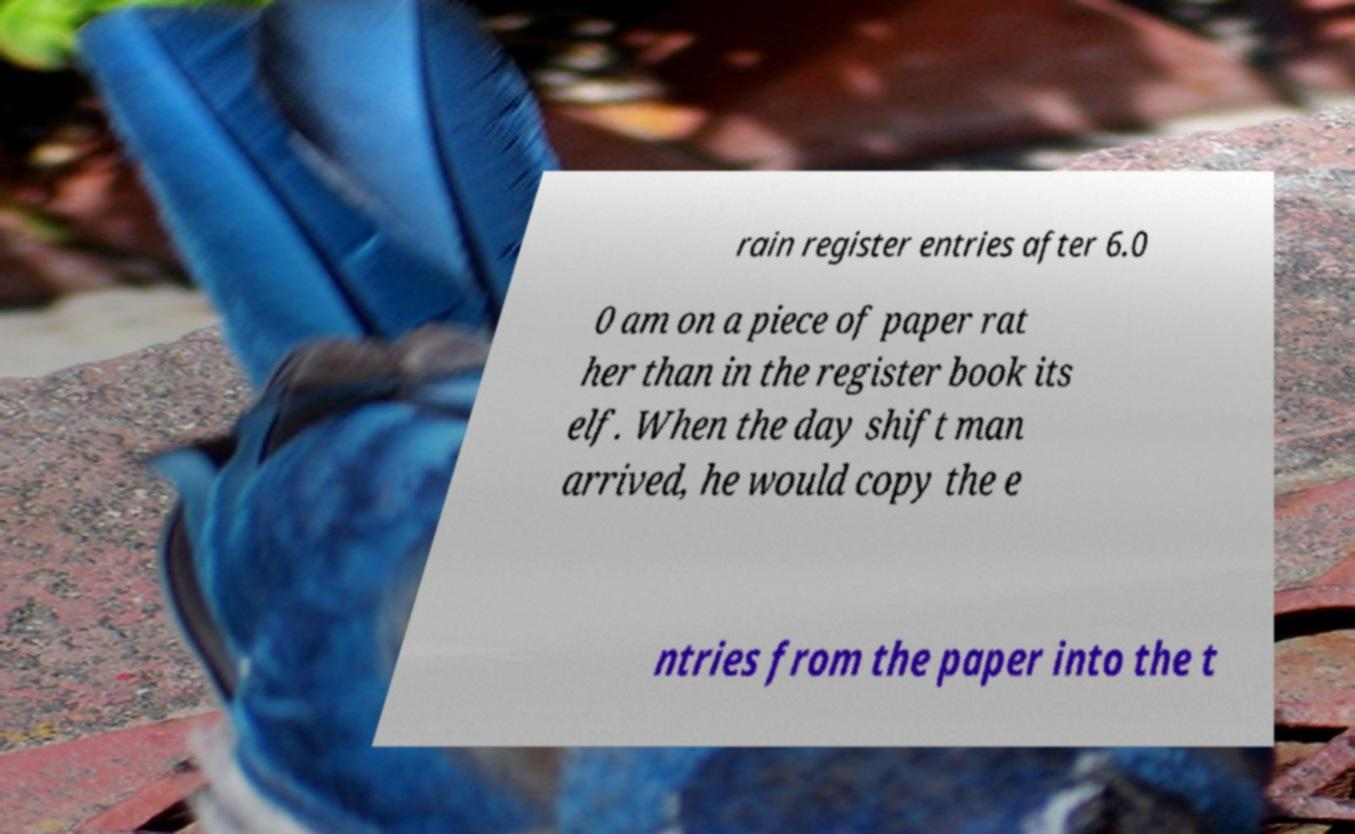Can you accurately transcribe the text from the provided image for me? rain register entries after 6.0 0 am on a piece of paper rat her than in the register book its elf. When the day shift man arrived, he would copy the e ntries from the paper into the t 